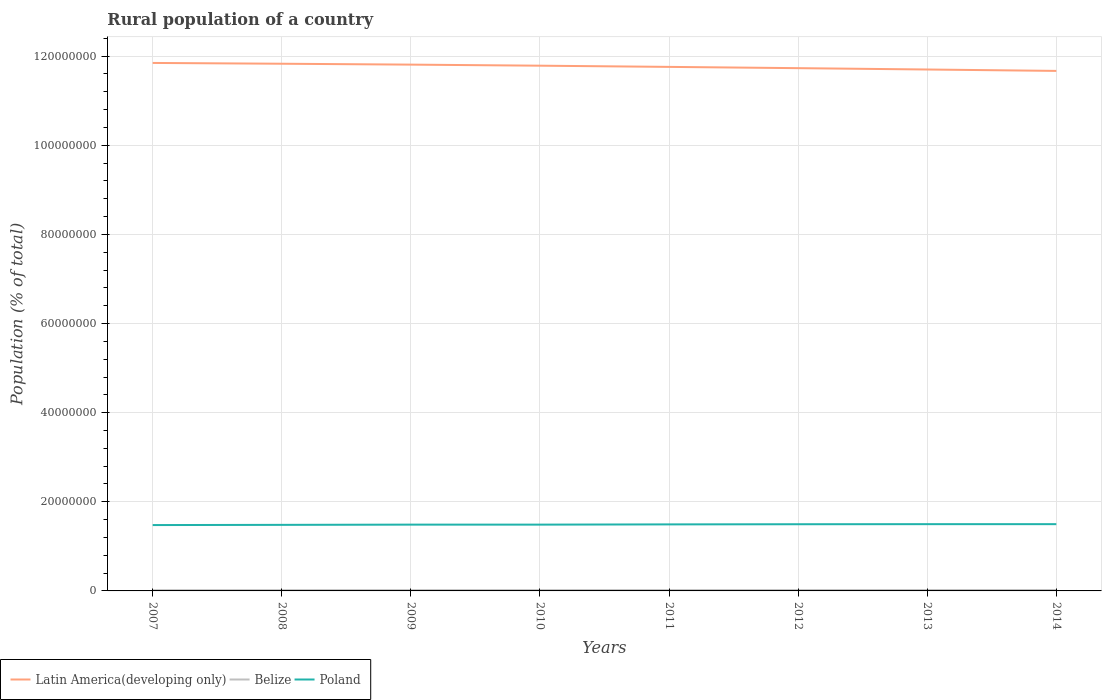How many different coloured lines are there?
Provide a short and direct response. 3. Is the number of lines equal to the number of legend labels?
Provide a short and direct response. Yes. Across all years, what is the maximum rural population in Poland?
Make the answer very short. 1.48e+07. In which year was the rural population in Latin America(developing only) maximum?
Give a very brief answer. 2014. What is the total rural population in Belize in the graph?
Give a very brief answer. -1.52e+04. What is the difference between the highest and the second highest rural population in Belize?
Your answer should be very brief. 3.47e+04. What is the difference between the highest and the lowest rural population in Poland?
Your answer should be compact. 4. Is the rural population in Poland strictly greater than the rural population in Belize over the years?
Your answer should be very brief. No. How many lines are there?
Offer a very short reply. 3. Are the values on the major ticks of Y-axis written in scientific E-notation?
Provide a succinct answer. No. Does the graph contain grids?
Make the answer very short. Yes. How many legend labels are there?
Make the answer very short. 3. How are the legend labels stacked?
Make the answer very short. Horizontal. What is the title of the graph?
Offer a terse response. Rural population of a country. Does "Albania" appear as one of the legend labels in the graph?
Provide a short and direct response. No. What is the label or title of the X-axis?
Your answer should be very brief. Years. What is the label or title of the Y-axis?
Ensure brevity in your answer.  Population (% of total). What is the Population (% of total) of Latin America(developing only) in 2007?
Provide a succinct answer. 1.18e+08. What is the Population (% of total) of Belize in 2007?
Your answer should be compact. 1.62e+05. What is the Population (% of total) of Poland in 2007?
Your response must be concise. 1.48e+07. What is the Population (% of total) in Latin America(developing only) in 2008?
Your response must be concise. 1.18e+08. What is the Population (% of total) in Belize in 2008?
Provide a short and direct response. 1.67e+05. What is the Population (% of total) of Poland in 2008?
Make the answer very short. 1.48e+07. What is the Population (% of total) of Latin America(developing only) in 2009?
Make the answer very short. 1.18e+08. What is the Population (% of total) in Belize in 2009?
Your response must be concise. 1.72e+05. What is the Population (% of total) of Poland in 2009?
Offer a very short reply. 1.49e+07. What is the Population (% of total) in Latin America(developing only) in 2010?
Give a very brief answer. 1.18e+08. What is the Population (% of total) in Belize in 2010?
Provide a short and direct response. 1.77e+05. What is the Population (% of total) in Poland in 2010?
Your answer should be very brief. 1.49e+07. What is the Population (% of total) of Latin America(developing only) in 2011?
Ensure brevity in your answer.  1.18e+08. What is the Population (% of total) of Belize in 2011?
Make the answer very short. 1.82e+05. What is the Population (% of total) in Poland in 2011?
Offer a terse response. 1.49e+07. What is the Population (% of total) of Latin America(developing only) in 2012?
Keep it short and to the point. 1.17e+08. What is the Population (% of total) in Belize in 2012?
Ensure brevity in your answer.  1.87e+05. What is the Population (% of total) of Poland in 2012?
Provide a short and direct response. 1.50e+07. What is the Population (% of total) in Latin America(developing only) in 2013?
Keep it short and to the point. 1.17e+08. What is the Population (% of total) in Belize in 2013?
Your response must be concise. 1.92e+05. What is the Population (% of total) of Poland in 2013?
Provide a short and direct response. 1.50e+07. What is the Population (% of total) of Latin America(developing only) in 2014?
Keep it short and to the point. 1.17e+08. What is the Population (% of total) of Belize in 2014?
Offer a very short reply. 1.97e+05. What is the Population (% of total) in Poland in 2014?
Make the answer very short. 1.50e+07. Across all years, what is the maximum Population (% of total) of Latin America(developing only)?
Provide a succinct answer. 1.18e+08. Across all years, what is the maximum Population (% of total) in Belize?
Ensure brevity in your answer.  1.97e+05. Across all years, what is the maximum Population (% of total) in Poland?
Provide a succinct answer. 1.50e+07. Across all years, what is the minimum Population (% of total) of Latin America(developing only)?
Provide a succinct answer. 1.17e+08. Across all years, what is the minimum Population (% of total) of Belize?
Offer a terse response. 1.62e+05. Across all years, what is the minimum Population (% of total) of Poland?
Your response must be concise. 1.48e+07. What is the total Population (% of total) in Latin America(developing only) in the graph?
Provide a succinct answer. 9.41e+08. What is the total Population (% of total) in Belize in the graph?
Your answer should be very brief. 1.43e+06. What is the total Population (% of total) in Poland in the graph?
Provide a short and direct response. 1.19e+08. What is the difference between the Population (% of total) of Latin America(developing only) in 2007 and that in 2008?
Keep it short and to the point. 1.78e+05. What is the difference between the Population (% of total) of Belize in 2007 and that in 2008?
Give a very brief answer. -5036. What is the difference between the Population (% of total) in Poland in 2007 and that in 2008?
Make the answer very short. -4.51e+04. What is the difference between the Population (% of total) of Latin America(developing only) in 2007 and that in 2009?
Your answer should be compact. 3.80e+05. What is the difference between the Population (% of total) in Belize in 2007 and that in 2009?
Offer a terse response. -1.01e+04. What is the difference between the Population (% of total) of Poland in 2007 and that in 2009?
Keep it short and to the point. -9.79e+04. What is the difference between the Population (% of total) in Latin America(developing only) in 2007 and that in 2010?
Your answer should be compact. 6.17e+05. What is the difference between the Population (% of total) in Belize in 2007 and that in 2010?
Your answer should be very brief. -1.52e+04. What is the difference between the Population (% of total) of Poland in 2007 and that in 2010?
Your answer should be compact. -9.81e+04. What is the difference between the Population (% of total) in Latin America(developing only) in 2007 and that in 2011?
Make the answer very short. 8.88e+05. What is the difference between the Population (% of total) in Belize in 2007 and that in 2011?
Offer a terse response. -2.02e+04. What is the difference between the Population (% of total) of Poland in 2007 and that in 2011?
Offer a very short reply. -1.49e+05. What is the difference between the Population (% of total) of Latin America(developing only) in 2007 and that in 2012?
Offer a very short reply. 1.17e+06. What is the difference between the Population (% of total) of Belize in 2007 and that in 2012?
Provide a short and direct response. -2.51e+04. What is the difference between the Population (% of total) of Poland in 2007 and that in 2012?
Provide a succinct answer. -1.84e+05. What is the difference between the Population (% of total) of Latin America(developing only) in 2007 and that in 2013?
Provide a short and direct response. 1.47e+06. What is the difference between the Population (% of total) in Belize in 2007 and that in 2013?
Offer a very short reply. -2.99e+04. What is the difference between the Population (% of total) in Poland in 2007 and that in 2013?
Provide a succinct answer. -2.02e+05. What is the difference between the Population (% of total) of Latin America(developing only) in 2007 and that in 2014?
Give a very brief answer. 1.79e+06. What is the difference between the Population (% of total) of Belize in 2007 and that in 2014?
Your response must be concise. -3.47e+04. What is the difference between the Population (% of total) of Poland in 2007 and that in 2014?
Provide a short and direct response. -2.03e+05. What is the difference between the Population (% of total) of Latin America(developing only) in 2008 and that in 2009?
Your answer should be very brief. 2.02e+05. What is the difference between the Population (% of total) of Belize in 2008 and that in 2009?
Make the answer very short. -5073. What is the difference between the Population (% of total) of Poland in 2008 and that in 2009?
Offer a terse response. -5.28e+04. What is the difference between the Population (% of total) of Latin America(developing only) in 2008 and that in 2010?
Keep it short and to the point. 4.39e+05. What is the difference between the Population (% of total) in Belize in 2008 and that in 2010?
Provide a succinct answer. -1.01e+04. What is the difference between the Population (% of total) in Poland in 2008 and that in 2010?
Your answer should be compact. -5.30e+04. What is the difference between the Population (% of total) in Latin America(developing only) in 2008 and that in 2011?
Your response must be concise. 7.09e+05. What is the difference between the Population (% of total) in Belize in 2008 and that in 2011?
Offer a terse response. -1.51e+04. What is the difference between the Population (% of total) of Poland in 2008 and that in 2011?
Your answer should be compact. -1.04e+05. What is the difference between the Population (% of total) in Latin America(developing only) in 2008 and that in 2012?
Your answer should be very brief. 9.94e+05. What is the difference between the Population (% of total) of Belize in 2008 and that in 2012?
Ensure brevity in your answer.  -2.00e+04. What is the difference between the Population (% of total) of Poland in 2008 and that in 2012?
Offer a terse response. -1.39e+05. What is the difference between the Population (% of total) in Latin America(developing only) in 2008 and that in 2013?
Offer a very short reply. 1.29e+06. What is the difference between the Population (% of total) in Belize in 2008 and that in 2013?
Your answer should be compact. -2.49e+04. What is the difference between the Population (% of total) in Poland in 2008 and that in 2013?
Provide a succinct answer. -1.57e+05. What is the difference between the Population (% of total) of Latin America(developing only) in 2008 and that in 2014?
Your answer should be very brief. 1.61e+06. What is the difference between the Population (% of total) of Belize in 2008 and that in 2014?
Give a very brief answer. -2.97e+04. What is the difference between the Population (% of total) of Poland in 2008 and that in 2014?
Keep it short and to the point. -1.58e+05. What is the difference between the Population (% of total) of Latin America(developing only) in 2009 and that in 2010?
Provide a succinct answer. 2.37e+05. What is the difference between the Population (% of total) of Belize in 2009 and that in 2010?
Make the answer very short. -5074. What is the difference between the Population (% of total) in Poland in 2009 and that in 2010?
Ensure brevity in your answer.  -177. What is the difference between the Population (% of total) of Latin America(developing only) in 2009 and that in 2011?
Provide a succinct answer. 5.07e+05. What is the difference between the Population (% of total) of Belize in 2009 and that in 2011?
Provide a succinct answer. -1.01e+04. What is the difference between the Population (% of total) of Poland in 2009 and that in 2011?
Offer a terse response. -5.08e+04. What is the difference between the Population (% of total) of Latin America(developing only) in 2009 and that in 2012?
Your response must be concise. 7.92e+05. What is the difference between the Population (% of total) in Belize in 2009 and that in 2012?
Provide a short and direct response. -1.50e+04. What is the difference between the Population (% of total) in Poland in 2009 and that in 2012?
Make the answer very short. -8.58e+04. What is the difference between the Population (% of total) of Latin America(developing only) in 2009 and that in 2013?
Ensure brevity in your answer.  1.09e+06. What is the difference between the Population (% of total) of Belize in 2009 and that in 2013?
Offer a terse response. -1.98e+04. What is the difference between the Population (% of total) of Poland in 2009 and that in 2013?
Ensure brevity in your answer.  -1.04e+05. What is the difference between the Population (% of total) in Latin America(developing only) in 2009 and that in 2014?
Offer a very short reply. 1.41e+06. What is the difference between the Population (% of total) of Belize in 2009 and that in 2014?
Your answer should be very brief. -2.46e+04. What is the difference between the Population (% of total) of Poland in 2009 and that in 2014?
Offer a very short reply. -1.05e+05. What is the difference between the Population (% of total) in Latin America(developing only) in 2010 and that in 2011?
Your answer should be compact. 2.71e+05. What is the difference between the Population (% of total) of Belize in 2010 and that in 2011?
Your answer should be very brief. -4980. What is the difference between the Population (% of total) of Poland in 2010 and that in 2011?
Provide a short and direct response. -5.06e+04. What is the difference between the Population (% of total) in Latin America(developing only) in 2010 and that in 2012?
Your answer should be compact. 5.55e+05. What is the difference between the Population (% of total) in Belize in 2010 and that in 2012?
Your answer should be very brief. -9882. What is the difference between the Population (% of total) in Poland in 2010 and that in 2012?
Offer a terse response. -8.56e+04. What is the difference between the Population (% of total) of Latin America(developing only) in 2010 and that in 2013?
Offer a terse response. 8.55e+05. What is the difference between the Population (% of total) in Belize in 2010 and that in 2013?
Your answer should be very brief. -1.47e+04. What is the difference between the Population (% of total) of Poland in 2010 and that in 2013?
Your response must be concise. -1.04e+05. What is the difference between the Population (% of total) in Latin America(developing only) in 2010 and that in 2014?
Give a very brief answer. 1.17e+06. What is the difference between the Population (% of total) of Belize in 2010 and that in 2014?
Your response must be concise. -1.95e+04. What is the difference between the Population (% of total) of Poland in 2010 and that in 2014?
Your response must be concise. -1.05e+05. What is the difference between the Population (% of total) of Latin America(developing only) in 2011 and that in 2012?
Keep it short and to the point. 2.85e+05. What is the difference between the Population (% of total) in Belize in 2011 and that in 2012?
Provide a short and direct response. -4902. What is the difference between the Population (% of total) of Poland in 2011 and that in 2012?
Your response must be concise. -3.50e+04. What is the difference between the Population (% of total) in Latin America(developing only) in 2011 and that in 2013?
Provide a succinct answer. 5.85e+05. What is the difference between the Population (% of total) of Belize in 2011 and that in 2013?
Offer a very short reply. -9738. What is the difference between the Population (% of total) of Poland in 2011 and that in 2013?
Ensure brevity in your answer.  -5.30e+04. What is the difference between the Population (% of total) in Latin America(developing only) in 2011 and that in 2014?
Ensure brevity in your answer.  9.02e+05. What is the difference between the Population (% of total) in Belize in 2011 and that in 2014?
Offer a very short reply. -1.45e+04. What is the difference between the Population (% of total) of Poland in 2011 and that in 2014?
Give a very brief answer. -5.40e+04. What is the difference between the Population (% of total) of Latin America(developing only) in 2012 and that in 2013?
Make the answer very short. 3.00e+05. What is the difference between the Population (% of total) of Belize in 2012 and that in 2013?
Ensure brevity in your answer.  -4836. What is the difference between the Population (% of total) of Poland in 2012 and that in 2013?
Your response must be concise. -1.80e+04. What is the difference between the Population (% of total) of Latin America(developing only) in 2012 and that in 2014?
Your answer should be very brief. 6.17e+05. What is the difference between the Population (% of total) of Belize in 2012 and that in 2014?
Make the answer very short. -9633. What is the difference between the Population (% of total) of Poland in 2012 and that in 2014?
Your answer should be compact. -1.90e+04. What is the difference between the Population (% of total) in Latin America(developing only) in 2013 and that in 2014?
Give a very brief answer. 3.17e+05. What is the difference between the Population (% of total) in Belize in 2013 and that in 2014?
Your answer should be very brief. -4797. What is the difference between the Population (% of total) of Poland in 2013 and that in 2014?
Provide a succinct answer. -1027. What is the difference between the Population (% of total) in Latin America(developing only) in 2007 and the Population (% of total) in Belize in 2008?
Your response must be concise. 1.18e+08. What is the difference between the Population (% of total) of Latin America(developing only) in 2007 and the Population (% of total) of Poland in 2008?
Ensure brevity in your answer.  1.04e+08. What is the difference between the Population (% of total) of Belize in 2007 and the Population (% of total) of Poland in 2008?
Make the answer very short. -1.47e+07. What is the difference between the Population (% of total) in Latin America(developing only) in 2007 and the Population (% of total) in Belize in 2009?
Offer a terse response. 1.18e+08. What is the difference between the Population (% of total) of Latin America(developing only) in 2007 and the Population (% of total) of Poland in 2009?
Offer a very short reply. 1.04e+08. What is the difference between the Population (% of total) of Belize in 2007 and the Population (% of total) of Poland in 2009?
Offer a very short reply. -1.47e+07. What is the difference between the Population (% of total) of Latin America(developing only) in 2007 and the Population (% of total) of Belize in 2010?
Your response must be concise. 1.18e+08. What is the difference between the Population (% of total) in Latin America(developing only) in 2007 and the Population (% of total) in Poland in 2010?
Keep it short and to the point. 1.04e+08. What is the difference between the Population (% of total) in Belize in 2007 and the Population (% of total) in Poland in 2010?
Ensure brevity in your answer.  -1.47e+07. What is the difference between the Population (% of total) in Latin America(developing only) in 2007 and the Population (% of total) in Belize in 2011?
Offer a terse response. 1.18e+08. What is the difference between the Population (% of total) of Latin America(developing only) in 2007 and the Population (% of total) of Poland in 2011?
Make the answer very short. 1.04e+08. What is the difference between the Population (% of total) of Belize in 2007 and the Population (% of total) of Poland in 2011?
Ensure brevity in your answer.  -1.48e+07. What is the difference between the Population (% of total) of Latin America(developing only) in 2007 and the Population (% of total) of Belize in 2012?
Provide a succinct answer. 1.18e+08. What is the difference between the Population (% of total) of Latin America(developing only) in 2007 and the Population (% of total) of Poland in 2012?
Your response must be concise. 1.04e+08. What is the difference between the Population (% of total) in Belize in 2007 and the Population (% of total) in Poland in 2012?
Keep it short and to the point. -1.48e+07. What is the difference between the Population (% of total) of Latin America(developing only) in 2007 and the Population (% of total) of Belize in 2013?
Offer a very short reply. 1.18e+08. What is the difference between the Population (% of total) of Latin America(developing only) in 2007 and the Population (% of total) of Poland in 2013?
Ensure brevity in your answer.  1.03e+08. What is the difference between the Population (% of total) in Belize in 2007 and the Population (% of total) in Poland in 2013?
Give a very brief answer. -1.48e+07. What is the difference between the Population (% of total) in Latin America(developing only) in 2007 and the Population (% of total) in Belize in 2014?
Your response must be concise. 1.18e+08. What is the difference between the Population (% of total) of Latin America(developing only) in 2007 and the Population (% of total) of Poland in 2014?
Your response must be concise. 1.03e+08. What is the difference between the Population (% of total) of Belize in 2007 and the Population (% of total) of Poland in 2014?
Keep it short and to the point. -1.48e+07. What is the difference between the Population (% of total) in Latin America(developing only) in 2008 and the Population (% of total) in Belize in 2009?
Offer a terse response. 1.18e+08. What is the difference between the Population (% of total) of Latin America(developing only) in 2008 and the Population (% of total) of Poland in 2009?
Provide a succinct answer. 1.03e+08. What is the difference between the Population (% of total) in Belize in 2008 and the Population (% of total) in Poland in 2009?
Give a very brief answer. -1.47e+07. What is the difference between the Population (% of total) in Latin America(developing only) in 2008 and the Population (% of total) in Belize in 2010?
Give a very brief answer. 1.18e+08. What is the difference between the Population (% of total) of Latin America(developing only) in 2008 and the Population (% of total) of Poland in 2010?
Keep it short and to the point. 1.03e+08. What is the difference between the Population (% of total) in Belize in 2008 and the Population (% of total) in Poland in 2010?
Your answer should be compact. -1.47e+07. What is the difference between the Population (% of total) in Latin America(developing only) in 2008 and the Population (% of total) in Belize in 2011?
Make the answer very short. 1.18e+08. What is the difference between the Population (% of total) in Latin America(developing only) in 2008 and the Population (% of total) in Poland in 2011?
Provide a short and direct response. 1.03e+08. What is the difference between the Population (% of total) of Belize in 2008 and the Population (% of total) of Poland in 2011?
Make the answer very short. -1.48e+07. What is the difference between the Population (% of total) in Latin America(developing only) in 2008 and the Population (% of total) in Belize in 2012?
Ensure brevity in your answer.  1.18e+08. What is the difference between the Population (% of total) in Latin America(developing only) in 2008 and the Population (% of total) in Poland in 2012?
Offer a terse response. 1.03e+08. What is the difference between the Population (% of total) of Belize in 2008 and the Population (% of total) of Poland in 2012?
Provide a succinct answer. -1.48e+07. What is the difference between the Population (% of total) of Latin America(developing only) in 2008 and the Population (% of total) of Belize in 2013?
Provide a short and direct response. 1.18e+08. What is the difference between the Population (% of total) in Latin America(developing only) in 2008 and the Population (% of total) in Poland in 2013?
Keep it short and to the point. 1.03e+08. What is the difference between the Population (% of total) in Belize in 2008 and the Population (% of total) in Poland in 2013?
Ensure brevity in your answer.  -1.48e+07. What is the difference between the Population (% of total) in Latin America(developing only) in 2008 and the Population (% of total) in Belize in 2014?
Provide a succinct answer. 1.18e+08. What is the difference between the Population (% of total) in Latin America(developing only) in 2008 and the Population (% of total) in Poland in 2014?
Ensure brevity in your answer.  1.03e+08. What is the difference between the Population (% of total) of Belize in 2008 and the Population (% of total) of Poland in 2014?
Provide a short and direct response. -1.48e+07. What is the difference between the Population (% of total) in Latin America(developing only) in 2009 and the Population (% of total) in Belize in 2010?
Give a very brief answer. 1.18e+08. What is the difference between the Population (% of total) in Latin America(developing only) in 2009 and the Population (% of total) in Poland in 2010?
Offer a terse response. 1.03e+08. What is the difference between the Population (% of total) of Belize in 2009 and the Population (% of total) of Poland in 2010?
Provide a short and direct response. -1.47e+07. What is the difference between the Population (% of total) in Latin America(developing only) in 2009 and the Population (% of total) in Belize in 2011?
Provide a succinct answer. 1.18e+08. What is the difference between the Population (% of total) of Latin America(developing only) in 2009 and the Population (% of total) of Poland in 2011?
Give a very brief answer. 1.03e+08. What is the difference between the Population (% of total) of Belize in 2009 and the Population (% of total) of Poland in 2011?
Your response must be concise. -1.48e+07. What is the difference between the Population (% of total) in Latin America(developing only) in 2009 and the Population (% of total) in Belize in 2012?
Make the answer very short. 1.18e+08. What is the difference between the Population (% of total) of Latin America(developing only) in 2009 and the Population (% of total) of Poland in 2012?
Provide a short and direct response. 1.03e+08. What is the difference between the Population (% of total) of Belize in 2009 and the Population (% of total) of Poland in 2012?
Provide a succinct answer. -1.48e+07. What is the difference between the Population (% of total) in Latin America(developing only) in 2009 and the Population (% of total) in Belize in 2013?
Give a very brief answer. 1.18e+08. What is the difference between the Population (% of total) in Latin America(developing only) in 2009 and the Population (% of total) in Poland in 2013?
Give a very brief answer. 1.03e+08. What is the difference between the Population (% of total) in Belize in 2009 and the Population (% of total) in Poland in 2013?
Your answer should be compact. -1.48e+07. What is the difference between the Population (% of total) of Latin America(developing only) in 2009 and the Population (% of total) of Belize in 2014?
Keep it short and to the point. 1.18e+08. What is the difference between the Population (% of total) in Latin America(developing only) in 2009 and the Population (% of total) in Poland in 2014?
Give a very brief answer. 1.03e+08. What is the difference between the Population (% of total) in Belize in 2009 and the Population (% of total) in Poland in 2014?
Offer a very short reply. -1.48e+07. What is the difference between the Population (% of total) of Latin America(developing only) in 2010 and the Population (% of total) of Belize in 2011?
Your answer should be very brief. 1.18e+08. What is the difference between the Population (% of total) of Latin America(developing only) in 2010 and the Population (% of total) of Poland in 2011?
Ensure brevity in your answer.  1.03e+08. What is the difference between the Population (% of total) in Belize in 2010 and the Population (% of total) in Poland in 2011?
Keep it short and to the point. -1.48e+07. What is the difference between the Population (% of total) of Latin America(developing only) in 2010 and the Population (% of total) of Belize in 2012?
Your answer should be compact. 1.18e+08. What is the difference between the Population (% of total) in Latin America(developing only) in 2010 and the Population (% of total) in Poland in 2012?
Your answer should be compact. 1.03e+08. What is the difference between the Population (% of total) in Belize in 2010 and the Population (% of total) in Poland in 2012?
Make the answer very short. -1.48e+07. What is the difference between the Population (% of total) of Latin America(developing only) in 2010 and the Population (% of total) of Belize in 2013?
Your response must be concise. 1.18e+08. What is the difference between the Population (% of total) in Latin America(developing only) in 2010 and the Population (% of total) in Poland in 2013?
Offer a very short reply. 1.03e+08. What is the difference between the Population (% of total) in Belize in 2010 and the Population (% of total) in Poland in 2013?
Your answer should be compact. -1.48e+07. What is the difference between the Population (% of total) of Latin America(developing only) in 2010 and the Population (% of total) of Belize in 2014?
Give a very brief answer. 1.18e+08. What is the difference between the Population (% of total) of Latin America(developing only) in 2010 and the Population (% of total) of Poland in 2014?
Offer a very short reply. 1.03e+08. What is the difference between the Population (% of total) of Belize in 2010 and the Population (% of total) of Poland in 2014?
Give a very brief answer. -1.48e+07. What is the difference between the Population (% of total) in Latin America(developing only) in 2011 and the Population (% of total) in Belize in 2012?
Offer a very short reply. 1.17e+08. What is the difference between the Population (% of total) of Latin America(developing only) in 2011 and the Population (% of total) of Poland in 2012?
Your answer should be compact. 1.03e+08. What is the difference between the Population (% of total) of Belize in 2011 and the Population (% of total) of Poland in 2012?
Keep it short and to the point. -1.48e+07. What is the difference between the Population (% of total) in Latin America(developing only) in 2011 and the Population (% of total) in Belize in 2013?
Make the answer very short. 1.17e+08. What is the difference between the Population (% of total) in Latin America(developing only) in 2011 and the Population (% of total) in Poland in 2013?
Your answer should be compact. 1.03e+08. What is the difference between the Population (% of total) in Belize in 2011 and the Population (% of total) in Poland in 2013?
Keep it short and to the point. -1.48e+07. What is the difference between the Population (% of total) in Latin America(developing only) in 2011 and the Population (% of total) in Belize in 2014?
Offer a terse response. 1.17e+08. What is the difference between the Population (% of total) in Latin America(developing only) in 2011 and the Population (% of total) in Poland in 2014?
Provide a short and direct response. 1.03e+08. What is the difference between the Population (% of total) in Belize in 2011 and the Population (% of total) in Poland in 2014?
Offer a terse response. -1.48e+07. What is the difference between the Population (% of total) in Latin America(developing only) in 2012 and the Population (% of total) in Belize in 2013?
Your answer should be very brief. 1.17e+08. What is the difference between the Population (% of total) of Latin America(developing only) in 2012 and the Population (% of total) of Poland in 2013?
Give a very brief answer. 1.02e+08. What is the difference between the Population (% of total) of Belize in 2012 and the Population (% of total) of Poland in 2013?
Offer a very short reply. -1.48e+07. What is the difference between the Population (% of total) in Latin America(developing only) in 2012 and the Population (% of total) in Belize in 2014?
Offer a very short reply. 1.17e+08. What is the difference between the Population (% of total) in Latin America(developing only) in 2012 and the Population (% of total) in Poland in 2014?
Your answer should be compact. 1.02e+08. What is the difference between the Population (% of total) in Belize in 2012 and the Population (% of total) in Poland in 2014?
Offer a terse response. -1.48e+07. What is the difference between the Population (% of total) of Latin America(developing only) in 2013 and the Population (% of total) of Belize in 2014?
Ensure brevity in your answer.  1.17e+08. What is the difference between the Population (% of total) in Latin America(developing only) in 2013 and the Population (% of total) in Poland in 2014?
Ensure brevity in your answer.  1.02e+08. What is the difference between the Population (% of total) in Belize in 2013 and the Population (% of total) in Poland in 2014?
Make the answer very short. -1.48e+07. What is the average Population (% of total) in Latin America(developing only) per year?
Provide a succinct answer. 1.18e+08. What is the average Population (% of total) of Belize per year?
Offer a terse response. 1.79e+05. What is the average Population (% of total) of Poland per year?
Ensure brevity in your answer.  1.49e+07. In the year 2007, what is the difference between the Population (% of total) of Latin America(developing only) and Population (% of total) of Belize?
Your answer should be compact. 1.18e+08. In the year 2007, what is the difference between the Population (% of total) in Latin America(developing only) and Population (% of total) in Poland?
Keep it short and to the point. 1.04e+08. In the year 2007, what is the difference between the Population (% of total) of Belize and Population (% of total) of Poland?
Your answer should be very brief. -1.46e+07. In the year 2008, what is the difference between the Population (% of total) of Latin America(developing only) and Population (% of total) of Belize?
Give a very brief answer. 1.18e+08. In the year 2008, what is the difference between the Population (% of total) in Latin America(developing only) and Population (% of total) in Poland?
Make the answer very short. 1.03e+08. In the year 2008, what is the difference between the Population (% of total) in Belize and Population (% of total) in Poland?
Offer a very short reply. -1.47e+07. In the year 2009, what is the difference between the Population (% of total) of Latin America(developing only) and Population (% of total) of Belize?
Offer a very short reply. 1.18e+08. In the year 2009, what is the difference between the Population (% of total) in Latin America(developing only) and Population (% of total) in Poland?
Your answer should be very brief. 1.03e+08. In the year 2009, what is the difference between the Population (% of total) of Belize and Population (% of total) of Poland?
Your response must be concise. -1.47e+07. In the year 2010, what is the difference between the Population (% of total) in Latin America(developing only) and Population (% of total) in Belize?
Give a very brief answer. 1.18e+08. In the year 2010, what is the difference between the Population (% of total) of Latin America(developing only) and Population (% of total) of Poland?
Your answer should be compact. 1.03e+08. In the year 2010, what is the difference between the Population (% of total) in Belize and Population (% of total) in Poland?
Your response must be concise. -1.47e+07. In the year 2011, what is the difference between the Population (% of total) in Latin America(developing only) and Population (% of total) in Belize?
Keep it short and to the point. 1.17e+08. In the year 2011, what is the difference between the Population (% of total) in Latin America(developing only) and Population (% of total) in Poland?
Provide a short and direct response. 1.03e+08. In the year 2011, what is the difference between the Population (% of total) of Belize and Population (% of total) of Poland?
Give a very brief answer. -1.47e+07. In the year 2012, what is the difference between the Population (% of total) in Latin America(developing only) and Population (% of total) in Belize?
Offer a very short reply. 1.17e+08. In the year 2012, what is the difference between the Population (% of total) in Latin America(developing only) and Population (% of total) in Poland?
Keep it short and to the point. 1.02e+08. In the year 2012, what is the difference between the Population (% of total) of Belize and Population (% of total) of Poland?
Offer a terse response. -1.48e+07. In the year 2013, what is the difference between the Population (% of total) of Latin America(developing only) and Population (% of total) of Belize?
Make the answer very short. 1.17e+08. In the year 2013, what is the difference between the Population (% of total) of Latin America(developing only) and Population (% of total) of Poland?
Make the answer very short. 1.02e+08. In the year 2013, what is the difference between the Population (% of total) in Belize and Population (% of total) in Poland?
Ensure brevity in your answer.  -1.48e+07. In the year 2014, what is the difference between the Population (% of total) of Latin America(developing only) and Population (% of total) of Belize?
Your answer should be very brief. 1.16e+08. In the year 2014, what is the difference between the Population (% of total) in Latin America(developing only) and Population (% of total) in Poland?
Your answer should be very brief. 1.02e+08. In the year 2014, what is the difference between the Population (% of total) in Belize and Population (% of total) in Poland?
Provide a succinct answer. -1.48e+07. What is the ratio of the Population (% of total) of Latin America(developing only) in 2007 to that in 2008?
Keep it short and to the point. 1. What is the ratio of the Population (% of total) in Belize in 2007 to that in 2008?
Provide a short and direct response. 0.97. What is the ratio of the Population (% of total) in Poland in 2007 to that in 2008?
Your response must be concise. 1. What is the ratio of the Population (% of total) in Latin America(developing only) in 2007 to that in 2010?
Your response must be concise. 1.01. What is the ratio of the Population (% of total) in Belize in 2007 to that in 2010?
Offer a very short reply. 0.91. What is the ratio of the Population (% of total) of Poland in 2007 to that in 2010?
Your response must be concise. 0.99. What is the ratio of the Population (% of total) in Latin America(developing only) in 2007 to that in 2011?
Provide a short and direct response. 1.01. What is the ratio of the Population (% of total) in Belize in 2007 to that in 2011?
Keep it short and to the point. 0.89. What is the ratio of the Population (% of total) in Poland in 2007 to that in 2011?
Offer a very short reply. 0.99. What is the ratio of the Population (% of total) of Belize in 2007 to that in 2012?
Give a very brief answer. 0.87. What is the ratio of the Population (% of total) in Latin America(developing only) in 2007 to that in 2013?
Your answer should be very brief. 1.01. What is the ratio of the Population (% of total) of Belize in 2007 to that in 2013?
Keep it short and to the point. 0.84. What is the ratio of the Population (% of total) in Poland in 2007 to that in 2013?
Your response must be concise. 0.99. What is the ratio of the Population (% of total) of Latin America(developing only) in 2007 to that in 2014?
Offer a terse response. 1.02. What is the ratio of the Population (% of total) in Belize in 2007 to that in 2014?
Your answer should be compact. 0.82. What is the ratio of the Population (% of total) in Poland in 2007 to that in 2014?
Make the answer very short. 0.99. What is the ratio of the Population (% of total) of Belize in 2008 to that in 2009?
Offer a terse response. 0.97. What is the ratio of the Population (% of total) in Poland in 2008 to that in 2009?
Keep it short and to the point. 1. What is the ratio of the Population (% of total) of Belize in 2008 to that in 2010?
Your response must be concise. 0.94. What is the ratio of the Population (% of total) in Latin America(developing only) in 2008 to that in 2011?
Your answer should be compact. 1.01. What is the ratio of the Population (% of total) of Belize in 2008 to that in 2011?
Provide a short and direct response. 0.92. What is the ratio of the Population (% of total) of Poland in 2008 to that in 2011?
Give a very brief answer. 0.99. What is the ratio of the Population (% of total) in Latin America(developing only) in 2008 to that in 2012?
Ensure brevity in your answer.  1.01. What is the ratio of the Population (% of total) in Belize in 2008 to that in 2012?
Give a very brief answer. 0.89. What is the ratio of the Population (% of total) in Poland in 2008 to that in 2012?
Provide a short and direct response. 0.99. What is the ratio of the Population (% of total) in Latin America(developing only) in 2008 to that in 2013?
Offer a very short reply. 1.01. What is the ratio of the Population (% of total) of Belize in 2008 to that in 2013?
Your answer should be very brief. 0.87. What is the ratio of the Population (% of total) of Poland in 2008 to that in 2013?
Provide a short and direct response. 0.99. What is the ratio of the Population (% of total) in Latin America(developing only) in 2008 to that in 2014?
Offer a very short reply. 1.01. What is the ratio of the Population (% of total) in Belize in 2008 to that in 2014?
Provide a succinct answer. 0.85. What is the ratio of the Population (% of total) in Belize in 2009 to that in 2010?
Your answer should be compact. 0.97. What is the ratio of the Population (% of total) in Belize in 2009 to that in 2011?
Make the answer very short. 0.94. What is the ratio of the Population (% of total) in Poland in 2009 to that in 2011?
Your answer should be very brief. 1. What is the ratio of the Population (% of total) in Latin America(developing only) in 2009 to that in 2012?
Ensure brevity in your answer.  1.01. What is the ratio of the Population (% of total) in Belize in 2009 to that in 2012?
Keep it short and to the point. 0.92. What is the ratio of the Population (% of total) in Latin America(developing only) in 2009 to that in 2013?
Offer a very short reply. 1.01. What is the ratio of the Population (% of total) in Belize in 2009 to that in 2013?
Provide a succinct answer. 0.9. What is the ratio of the Population (% of total) of Poland in 2009 to that in 2013?
Provide a short and direct response. 0.99. What is the ratio of the Population (% of total) of Latin America(developing only) in 2009 to that in 2014?
Your answer should be compact. 1.01. What is the ratio of the Population (% of total) of Belize in 2009 to that in 2014?
Make the answer very short. 0.87. What is the ratio of the Population (% of total) of Poland in 2009 to that in 2014?
Offer a terse response. 0.99. What is the ratio of the Population (% of total) of Latin America(developing only) in 2010 to that in 2011?
Make the answer very short. 1. What is the ratio of the Population (% of total) in Belize in 2010 to that in 2011?
Make the answer very short. 0.97. What is the ratio of the Population (% of total) in Belize in 2010 to that in 2012?
Keep it short and to the point. 0.95. What is the ratio of the Population (% of total) of Poland in 2010 to that in 2012?
Provide a succinct answer. 0.99. What is the ratio of the Population (% of total) in Latin America(developing only) in 2010 to that in 2013?
Give a very brief answer. 1.01. What is the ratio of the Population (% of total) in Belize in 2010 to that in 2013?
Provide a short and direct response. 0.92. What is the ratio of the Population (% of total) in Poland in 2010 to that in 2013?
Give a very brief answer. 0.99. What is the ratio of the Population (% of total) in Belize in 2010 to that in 2014?
Provide a short and direct response. 0.9. What is the ratio of the Population (% of total) in Belize in 2011 to that in 2012?
Your answer should be very brief. 0.97. What is the ratio of the Population (% of total) of Latin America(developing only) in 2011 to that in 2013?
Provide a succinct answer. 1. What is the ratio of the Population (% of total) in Belize in 2011 to that in 2013?
Ensure brevity in your answer.  0.95. What is the ratio of the Population (% of total) of Poland in 2011 to that in 2013?
Ensure brevity in your answer.  1. What is the ratio of the Population (% of total) in Latin America(developing only) in 2011 to that in 2014?
Provide a short and direct response. 1.01. What is the ratio of the Population (% of total) of Belize in 2011 to that in 2014?
Your answer should be compact. 0.93. What is the ratio of the Population (% of total) of Latin America(developing only) in 2012 to that in 2013?
Offer a very short reply. 1. What is the ratio of the Population (% of total) in Belize in 2012 to that in 2013?
Keep it short and to the point. 0.97. What is the ratio of the Population (% of total) in Belize in 2012 to that in 2014?
Offer a very short reply. 0.95. What is the ratio of the Population (% of total) in Latin America(developing only) in 2013 to that in 2014?
Make the answer very short. 1. What is the ratio of the Population (% of total) of Belize in 2013 to that in 2014?
Make the answer very short. 0.98. What is the ratio of the Population (% of total) of Poland in 2013 to that in 2014?
Ensure brevity in your answer.  1. What is the difference between the highest and the second highest Population (% of total) in Latin America(developing only)?
Offer a terse response. 1.78e+05. What is the difference between the highest and the second highest Population (% of total) in Belize?
Offer a very short reply. 4797. What is the difference between the highest and the second highest Population (% of total) in Poland?
Provide a succinct answer. 1027. What is the difference between the highest and the lowest Population (% of total) in Latin America(developing only)?
Your response must be concise. 1.79e+06. What is the difference between the highest and the lowest Population (% of total) in Belize?
Your answer should be very brief. 3.47e+04. What is the difference between the highest and the lowest Population (% of total) of Poland?
Offer a terse response. 2.03e+05. 